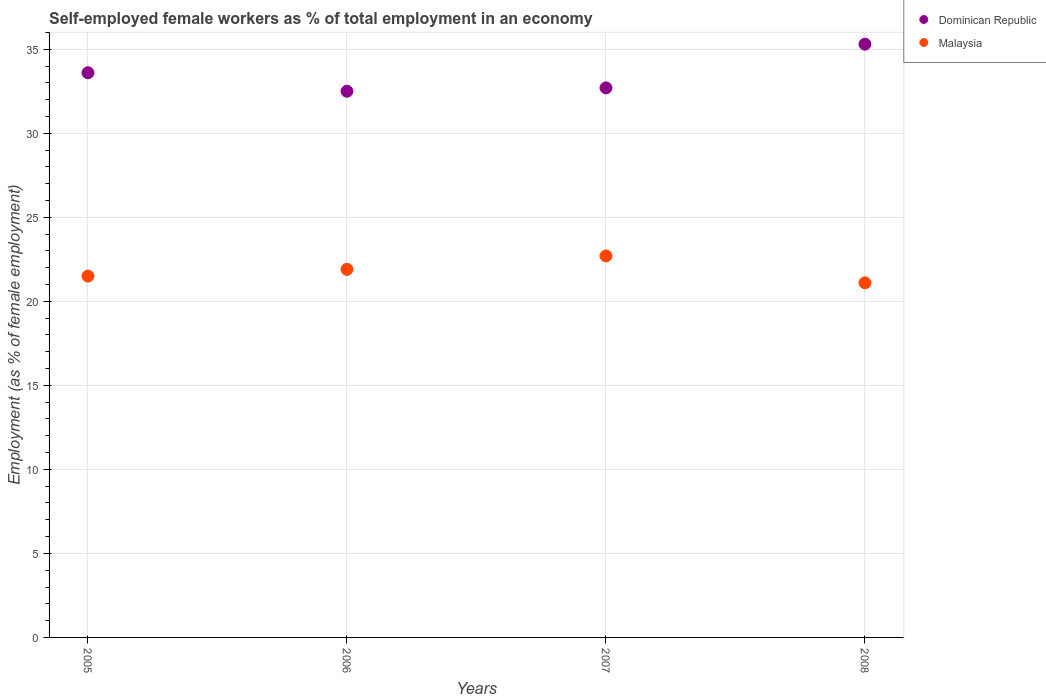Is the number of dotlines equal to the number of legend labels?
Make the answer very short. Yes. What is the percentage of self-employed female workers in Dominican Republic in 2007?
Provide a succinct answer. 32.7. Across all years, what is the maximum percentage of self-employed female workers in Malaysia?
Offer a terse response. 22.7. Across all years, what is the minimum percentage of self-employed female workers in Malaysia?
Provide a succinct answer. 21.1. In which year was the percentage of self-employed female workers in Malaysia maximum?
Provide a succinct answer. 2007. In which year was the percentage of self-employed female workers in Dominican Republic minimum?
Ensure brevity in your answer.  2006. What is the total percentage of self-employed female workers in Malaysia in the graph?
Give a very brief answer. 87.2. What is the difference between the percentage of self-employed female workers in Malaysia in 2005 and that in 2007?
Give a very brief answer. -1.2. What is the difference between the percentage of self-employed female workers in Malaysia in 2006 and the percentage of self-employed female workers in Dominican Republic in 2007?
Provide a succinct answer. -10.8. What is the average percentage of self-employed female workers in Dominican Republic per year?
Provide a succinct answer. 33.52. In the year 2008, what is the difference between the percentage of self-employed female workers in Malaysia and percentage of self-employed female workers in Dominican Republic?
Offer a very short reply. -14.2. In how many years, is the percentage of self-employed female workers in Malaysia greater than 8 %?
Keep it short and to the point. 4. What is the ratio of the percentage of self-employed female workers in Dominican Republic in 2006 to that in 2007?
Provide a short and direct response. 0.99. Is the percentage of self-employed female workers in Dominican Republic in 2005 less than that in 2008?
Give a very brief answer. Yes. Is the difference between the percentage of self-employed female workers in Malaysia in 2006 and 2007 greater than the difference between the percentage of self-employed female workers in Dominican Republic in 2006 and 2007?
Keep it short and to the point. No. What is the difference between the highest and the second highest percentage of self-employed female workers in Dominican Republic?
Offer a very short reply. 1.7. What is the difference between the highest and the lowest percentage of self-employed female workers in Malaysia?
Keep it short and to the point. 1.6. In how many years, is the percentage of self-employed female workers in Dominican Republic greater than the average percentage of self-employed female workers in Dominican Republic taken over all years?
Offer a very short reply. 2. Does the percentage of self-employed female workers in Malaysia monotonically increase over the years?
Your answer should be very brief. No. Is the percentage of self-employed female workers in Malaysia strictly greater than the percentage of self-employed female workers in Dominican Republic over the years?
Give a very brief answer. No. Is the percentage of self-employed female workers in Dominican Republic strictly less than the percentage of self-employed female workers in Malaysia over the years?
Your response must be concise. No. How many years are there in the graph?
Your answer should be very brief. 4. Does the graph contain grids?
Your answer should be very brief. Yes. Where does the legend appear in the graph?
Keep it short and to the point. Top right. What is the title of the graph?
Your answer should be compact. Self-employed female workers as % of total employment in an economy. Does "Tunisia" appear as one of the legend labels in the graph?
Your response must be concise. No. What is the label or title of the X-axis?
Provide a succinct answer. Years. What is the label or title of the Y-axis?
Offer a very short reply. Employment (as % of female employment). What is the Employment (as % of female employment) in Dominican Republic in 2005?
Keep it short and to the point. 33.6. What is the Employment (as % of female employment) of Malaysia in 2005?
Keep it short and to the point. 21.5. What is the Employment (as % of female employment) in Dominican Republic in 2006?
Give a very brief answer. 32.5. What is the Employment (as % of female employment) in Malaysia in 2006?
Provide a short and direct response. 21.9. What is the Employment (as % of female employment) in Dominican Republic in 2007?
Provide a short and direct response. 32.7. What is the Employment (as % of female employment) in Malaysia in 2007?
Offer a terse response. 22.7. What is the Employment (as % of female employment) of Dominican Republic in 2008?
Offer a terse response. 35.3. What is the Employment (as % of female employment) in Malaysia in 2008?
Offer a very short reply. 21.1. Across all years, what is the maximum Employment (as % of female employment) of Dominican Republic?
Provide a succinct answer. 35.3. Across all years, what is the maximum Employment (as % of female employment) of Malaysia?
Give a very brief answer. 22.7. Across all years, what is the minimum Employment (as % of female employment) of Dominican Republic?
Make the answer very short. 32.5. Across all years, what is the minimum Employment (as % of female employment) of Malaysia?
Your response must be concise. 21.1. What is the total Employment (as % of female employment) of Dominican Republic in the graph?
Offer a very short reply. 134.1. What is the total Employment (as % of female employment) of Malaysia in the graph?
Give a very brief answer. 87.2. What is the difference between the Employment (as % of female employment) of Dominican Republic in 2005 and that in 2006?
Offer a very short reply. 1.1. What is the difference between the Employment (as % of female employment) in Dominican Republic in 2005 and that in 2007?
Your response must be concise. 0.9. What is the difference between the Employment (as % of female employment) of Malaysia in 2005 and that in 2007?
Your answer should be compact. -1.2. What is the difference between the Employment (as % of female employment) of Malaysia in 2006 and that in 2008?
Your answer should be very brief. 0.8. What is the difference between the Employment (as % of female employment) of Malaysia in 2007 and that in 2008?
Provide a short and direct response. 1.6. What is the difference between the Employment (as % of female employment) in Dominican Republic in 2005 and the Employment (as % of female employment) in Malaysia in 2006?
Offer a terse response. 11.7. What is the difference between the Employment (as % of female employment) of Dominican Republic in 2005 and the Employment (as % of female employment) of Malaysia in 2007?
Ensure brevity in your answer.  10.9. What is the difference between the Employment (as % of female employment) in Dominican Republic in 2006 and the Employment (as % of female employment) in Malaysia in 2007?
Provide a succinct answer. 9.8. What is the difference between the Employment (as % of female employment) of Dominican Republic in 2006 and the Employment (as % of female employment) of Malaysia in 2008?
Offer a terse response. 11.4. What is the difference between the Employment (as % of female employment) of Dominican Republic in 2007 and the Employment (as % of female employment) of Malaysia in 2008?
Keep it short and to the point. 11.6. What is the average Employment (as % of female employment) in Dominican Republic per year?
Your answer should be very brief. 33.52. What is the average Employment (as % of female employment) of Malaysia per year?
Provide a short and direct response. 21.8. What is the ratio of the Employment (as % of female employment) in Dominican Republic in 2005 to that in 2006?
Offer a terse response. 1.03. What is the ratio of the Employment (as % of female employment) of Malaysia in 2005 to that in 2006?
Offer a terse response. 0.98. What is the ratio of the Employment (as % of female employment) in Dominican Republic in 2005 to that in 2007?
Your answer should be compact. 1.03. What is the ratio of the Employment (as % of female employment) of Malaysia in 2005 to that in 2007?
Offer a terse response. 0.95. What is the ratio of the Employment (as % of female employment) in Dominican Republic in 2005 to that in 2008?
Your response must be concise. 0.95. What is the ratio of the Employment (as % of female employment) in Malaysia in 2005 to that in 2008?
Your answer should be compact. 1.02. What is the ratio of the Employment (as % of female employment) in Dominican Republic in 2006 to that in 2007?
Offer a very short reply. 0.99. What is the ratio of the Employment (as % of female employment) of Malaysia in 2006 to that in 2007?
Offer a terse response. 0.96. What is the ratio of the Employment (as % of female employment) in Dominican Republic in 2006 to that in 2008?
Your answer should be compact. 0.92. What is the ratio of the Employment (as % of female employment) of Malaysia in 2006 to that in 2008?
Your response must be concise. 1.04. What is the ratio of the Employment (as % of female employment) of Dominican Republic in 2007 to that in 2008?
Offer a terse response. 0.93. What is the ratio of the Employment (as % of female employment) of Malaysia in 2007 to that in 2008?
Offer a terse response. 1.08. What is the difference between the highest and the lowest Employment (as % of female employment) of Malaysia?
Offer a terse response. 1.6. 